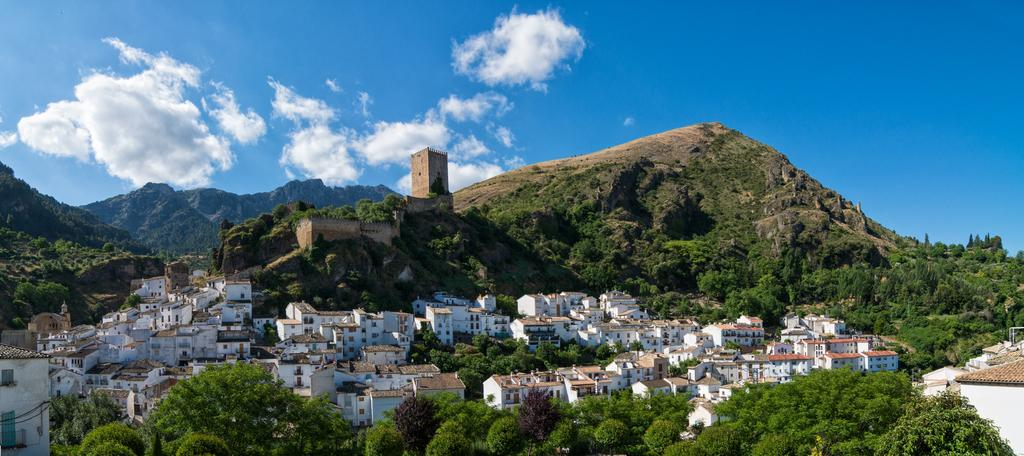What type of structures can be seen in the image? There are houses and buildings in the image. What other natural elements are present in the image? There are trees in the image. What is the main subject of the image? The image appears to depict a fort. Where is the fort located? The fort is located on a hill. What can be seen in the background of the image? The hills are visible in the image. What is the condition of the sky in the image? There are clouds in the sky. Can you tell me how many frogs are hopping around the fort in the image? There are no frogs present in the image; it features a fort located on a hill with surrounding trees and clouds in the sky. What is the argument about in the image? There is no argument depicted in the image; it focuses on the fort, surrounding structures, trees, and the sky. 